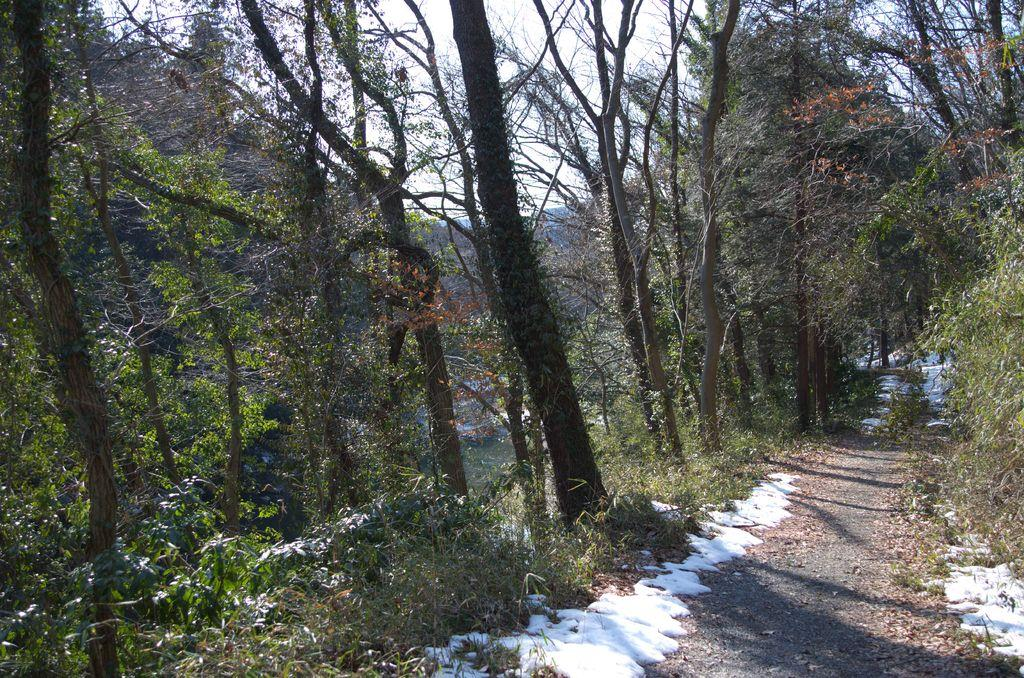What can be seen in the sky in the image? The sky is visible in the image. What type of vegetation is present in the image? There are trees in the image. What kind of surface can be seen in the image? There is a pathway in the image. What is covering the ground in the image? The ground appears to be covered in snow. What type of area is depicted in the image? The image depicts a forest area. What type of leather can be seen hanging from the trees in the image? There is no leather present in the image; it depicts a forest area with trees, sky, and snow-covered ground. 